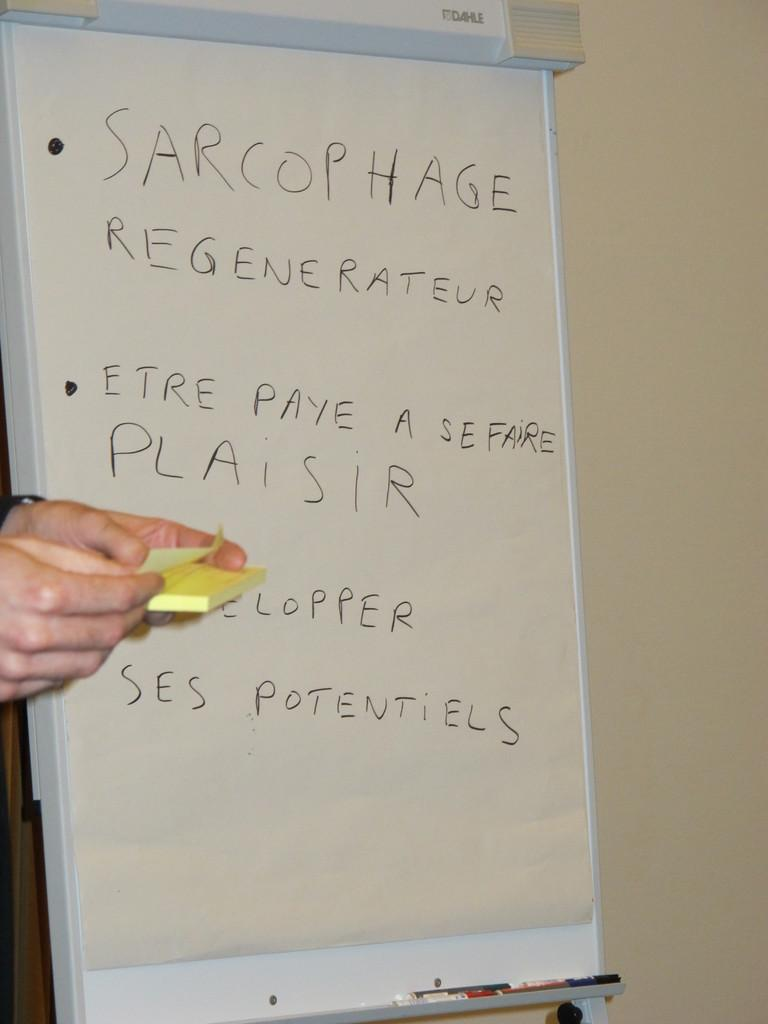<image>
Summarize the visual content of the image. Person in front of a white board which says "Sarcophage" on the top. 